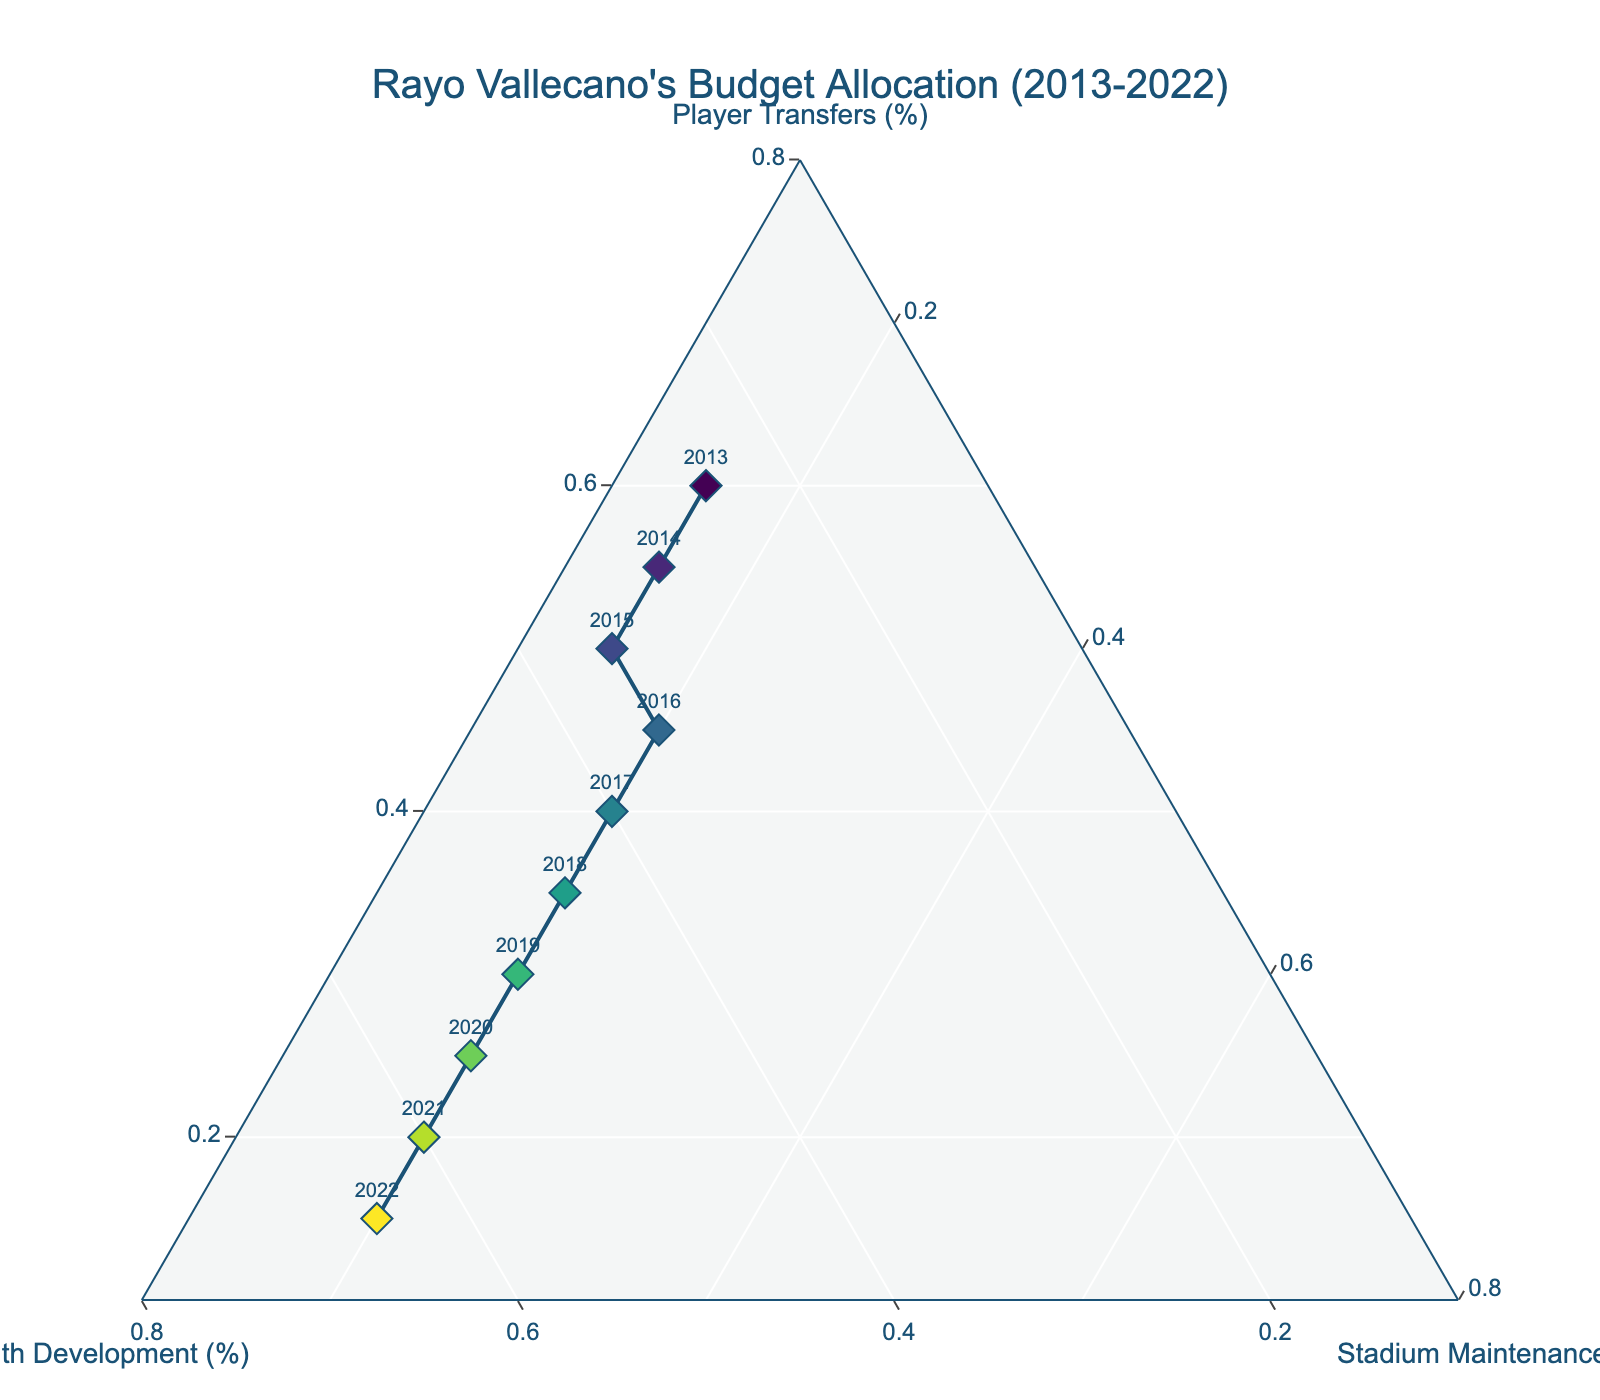Which year has the highest percentage allocated to Youth Development? From the plot, we identify the year corresponding to the highest position on the axis labeled "Youth Development (%)" which is at the top corner of the ternary plot. This happens to be 2022.
Answer: 2022 What is the title of the ternary plot? The title of the plot is written at the very top and is usually in larger text. It reads "Rayo Vallecano's Budget Allocation (2013-2022)".
Answer: Rayo Vallecano's Budget Allocation (2013-2022) How many data points are represented in the plot? Counting the markers or dots in the plot, especially considering each represents a year, we count 10 markers which corresponds to the years 2013-2022.
Answer: 10 Which color scale is used to represent the years in the plot? By looking at the plot, the varying colors from light to dark indicate a use of the "Viridis" color scale as mentioned in the code.
Answer: Viridis Which budget category has seen the most significant decrease in percentage allocation over the years? Observing the trend on the plot, the percentage allocation for "Player Transfers" (bottom corner) decreases consistently from 2013 to 2022, indicating a significant decrease over the years.
Answer: Player Transfers In which years is the allocation between Youth Development and Stadium Maintenance equal? Checking the plot, equality of two axes happens along lines parallel to the third axis. Here, Youth Development equals Stadium Maintenance in the years 2017 and 2018 where both are at 40% and 20% respectively.
Answer: 2017, 2018 What is the median percentage allocation for Stadium Maintenance over the years? Listing the percentages for Stadium Maintenance (fixed across years), they are 15, 15, 15, 20, 20, 20, 20, 20, 20, 20. Sorting these, the median value (middle values of 15, 15, 15, (20), 20, 20, 20, 20, 20, 20) is 20%.
Answer: 20% How does the percentage for Player Transfers change from 2013 to 2022? From 2013 to 2022, the percentage for Player Transfers decreases from 60% to 15% as seen via the descending trend towards the axis from left to right.
Answer: Decrease from 60% to 15% Which year marks the start of a consistent annual increase in the allocation for Youth Development? Identifying the points where Youth Development starts to increase annually in percentage, this change begins around 2014 and continues upward each subsequent year.
Answer: 2014 